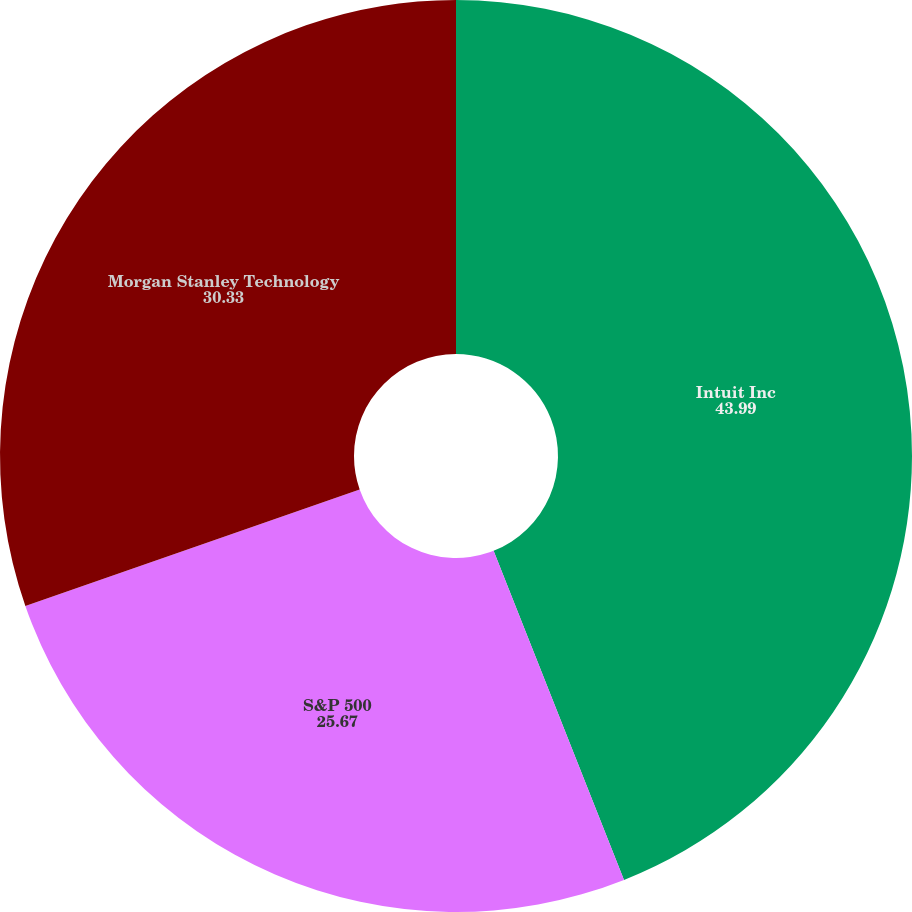Convert chart to OTSL. <chart><loc_0><loc_0><loc_500><loc_500><pie_chart><fcel>Intuit Inc<fcel>S&P 500<fcel>Morgan Stanley Technology<nl><fcel>43.99%<fcel>25.67%<fcel>30.33%<nl></chart> 